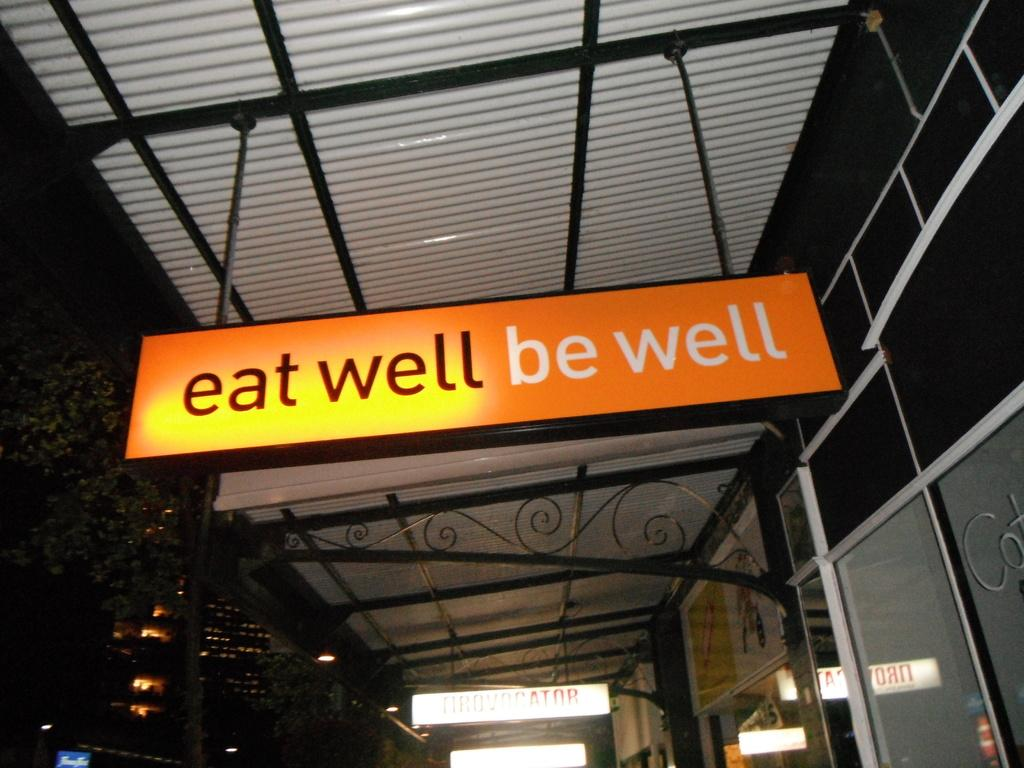What object is the main focus of the image? There is a board in the image. What is the color of the board? The board is orange in color. How is the board positioned in the image? The board is attached to a pole. What can be seen in the background of the image? There is a gray roof and glass doors visible in the background. How many chickens are standing on the button in the image? There are no chickens or buttons present in the image. 